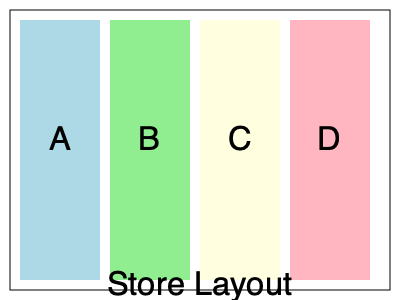Given the store layout diagram, where sections A, B, C, and D represent different product categories, you want to optimize shelf space allocation for essential items that are frequently purchased by single mothers. If the profit margins for sections A, B, C, and D are 15%, 20%, 25%, and 30% respectively, and the space utilization efficiencies are 0.8, 0.9, 0.7, and 0.6, which section should be prioritized for essential items to maximize both profitability and accessibility for single mothers? To determine the best section for essential items, we need to consider both profitability and accessibility. Let's approach this step-by-step:

1. Calculate the efficiency-adjusted profit margin for each section:
   Section A: $0.15 \times 0.8 = 0.12$ or 12%
   Section B: $0.20 \times 0.9 = 0.18$ or 18%
   Section C: $0.25 \times 0.7 = 0.175$ or 17.5%
   Section D: $0.30 \times 0.6 = 0.18$ or 18%

2. Rank the sections based on efficiency-adjusted profit margin:
   B and D (tie) > C > A

3. Consider accessibility:
   Sections closer to the entrance (A and B) are generally more accessible.

4. Balancing profitability and accessibility:
   Section B offers the highest efficiency-adjusted profit margin (18%) and is also near the entrance, making it more accessible.

5. Additional considerations:
   - Section B's higher space utilization efficiency (0.9) means more items can be displayed in the same area.
   - Placing essential items in Section B allows for easy restocking and monitoring.

Therefore, Section B is the optimal choice for essential items, balancing profitability and accessibility for single mothers.
Answer: Section B 